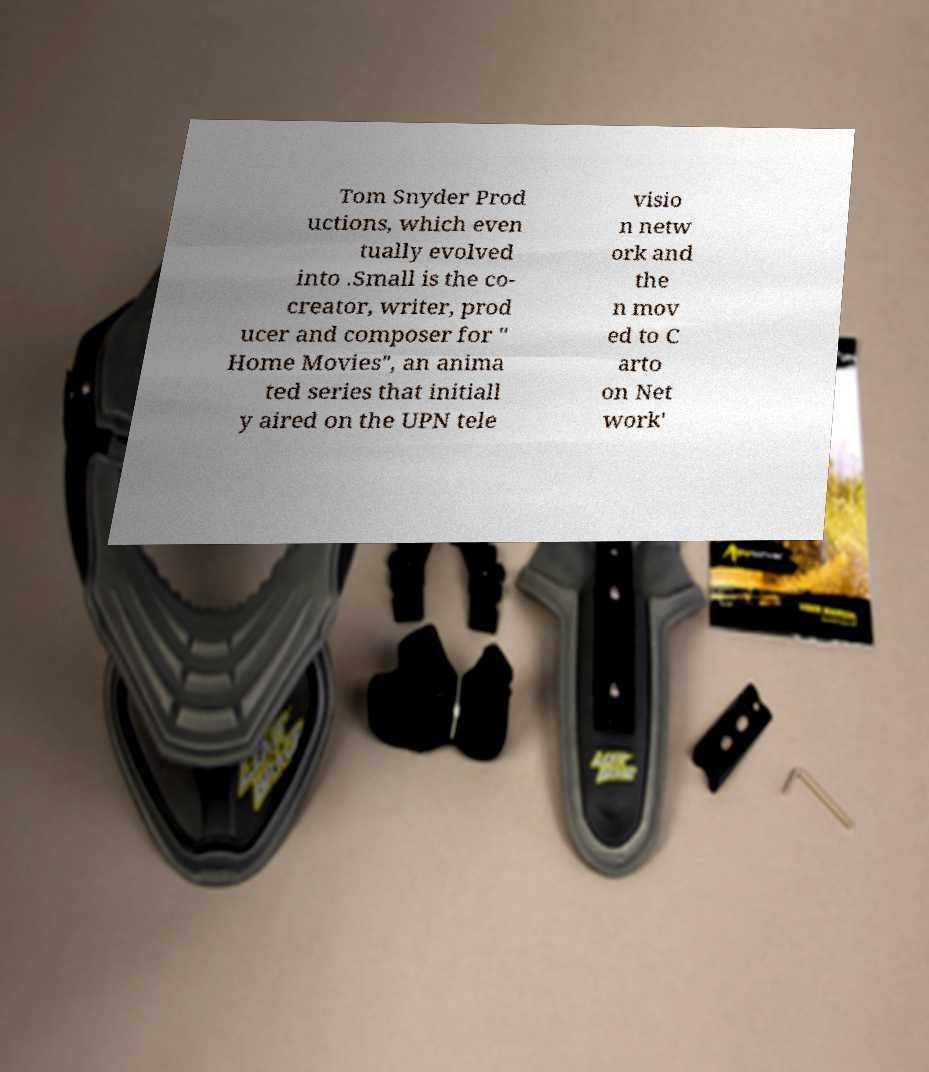I need the written content from this picture converted into text. Can you do that? Tom Snyder Prod uctions, which even tually evolved into .Small is the co- creator, writer, prod ucer and composer for " Home Movies", an anima ted series that initiall y aired on the UPN tele visio n netw ork and the n mov ed to C arto on Net work' 